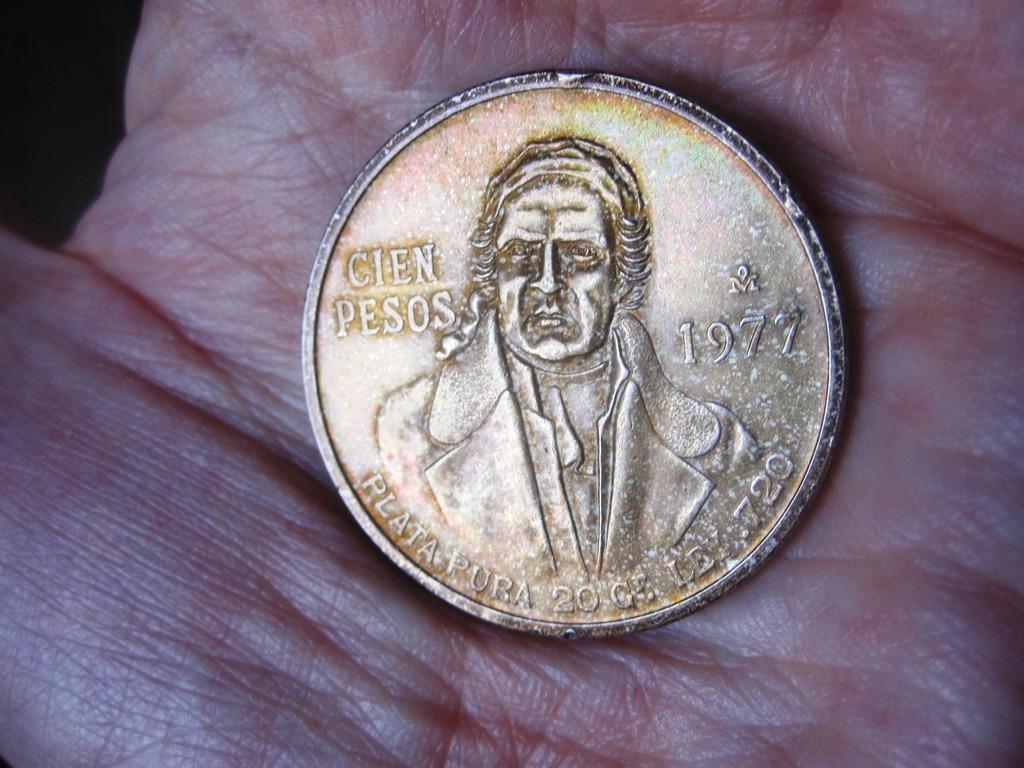<image>
Describe the image concisely. A 1977 coin with a man's photo labeled Cien Pesos 